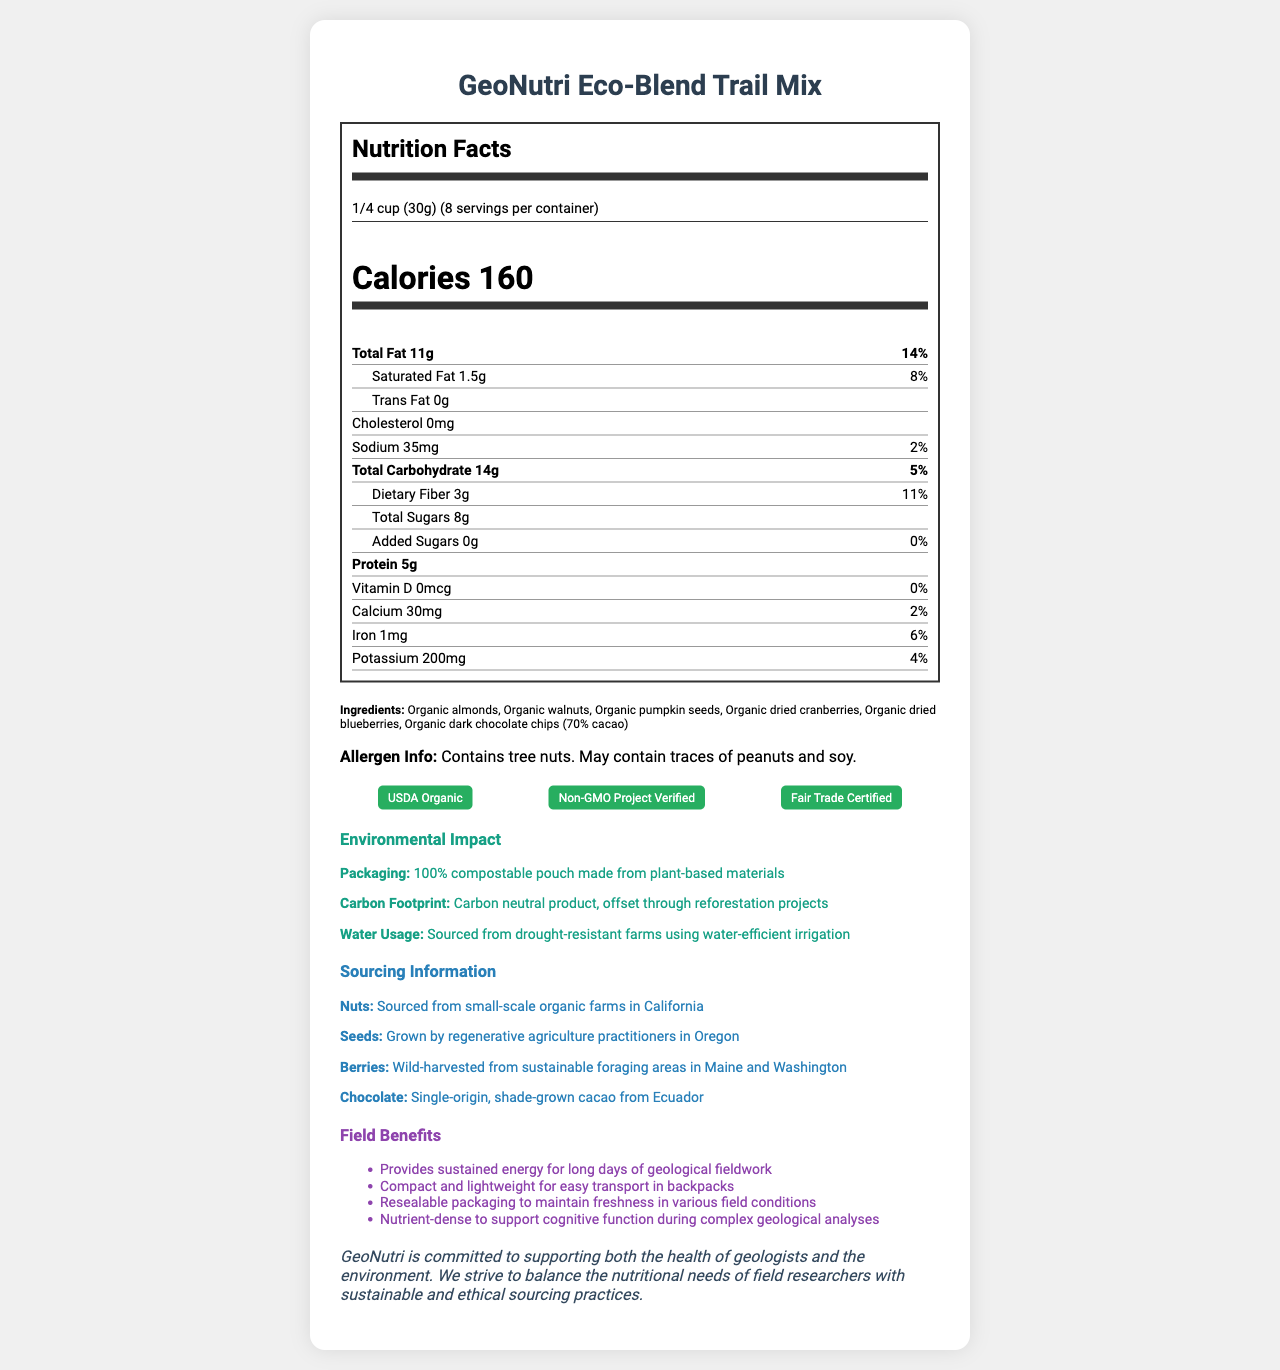what is the serving size of GeoNutri Eco-Blend Trail Mix? The serving size is listed at the top of the nutrition facts section as 1/4 cup (30g).
Answer: 1/4 cup (30g) how many calories are in one serving? The number of calories per serving is prominently displayed as 160.
Answer: 160 what is the total fat content per serving? The total fat content is listed as 11g in the nutrition facts.
Answer: 11g how much dietary fiber is in one serving? The dietary fiber content per serving is given as 3g.
Answer: 3g does this trail mix contain any trans fat? Trans fat content is listed as 0g in the nutrition facts.
Answer: No how much protein is in one serving? The protein content per serving is specified as 5g in the nutrition facts.
Answer: 5g where are the nuts in this trail mix sourced from? The sourcing information specifies that the nuts are sourced from small-scale organic farms in California.
Answer: small-scale organic farms in California is this product USDA Organic certified? The certifications section includes "USDA Organic."
Answer: Yes what type of packaging is used for this product? A. Plastic B. Paper C. Compostable pouch The environmental impact section states that the packaging is "100% compostable pouch made from plant-based materials."
Answer: C which agricultural practices are used to grow the seeds in this trail mix? A. Conventional farming B. Regenerative agriculture C. Hydroponics The sourcing information states that the seeds are grown by "regenerative agriculture practitioners in Oregon."
Answer: B does this trail mix contain any added sugars? The nutrition facts list added sugars as 0g with a 0% daily value.
Answer: No is this trail mix carbon neutral? The environmental impact section mentions "Carbon neutral product, offset through reforestation projects."
Answer: Yes what certifications does this product have? The certifications section lists "USDA Organic," "Non-GMO Project Verified," and "Fair Trade Certified."
Answer: USDA Organic, Non-GMO Project Verified, Fair Trade Certified what are the main ingredients in GeoNutri Eco-Blend Trail Mix? The ingredients section lists these main ingredients.
Answer: Organic almonds, Organic walnuts, Organic pumpkin seeds, Organic dried cranberries, Organic dried blueberries, Organic dark chocolate chips (70% cacao) is this product suitable for people who are allergic to tree nuts? The allergen information states that it contains tree nuts and may contain traces of peanuts and soy.
Answer: No how does this product support geologists in the field? The field benefits section lists these features supporting geological fieldwork.
Answer: Provides sustained energy, compact and lightweight, resealable packaging, nutrient-dense for cognitive function summarize the main idea of this document. The document provides detailed nutrition facts, ingredient sourcing, environmental benefits, and specific advantages for fieldwork, reflecting a balance between nutrition and environmental responsibility.
Answer: The document is a nutrition label for GeoNutri Eco-Blend Trail Mix, an organic and locally-sourced product designed for geologists in the field. It highlights the nutritional content, environmental impact, sourcing practices, and field benefits while emphasizing the company's commitment to health and sustainability. how many grams of sodium are in one serving? The sodium content is listed in milligrams (35mg), not grams.
Answer: Cannot be determined 